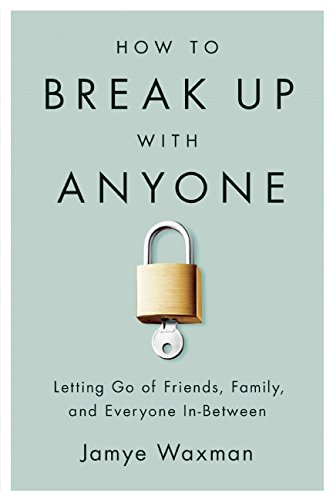What is the title of this book? The title of the book is 'How to Break Up With Anyone: Letting Go of Friends, Family, and Everyone In-Between', covering advice on ending personal relationships in a healthy manner. 